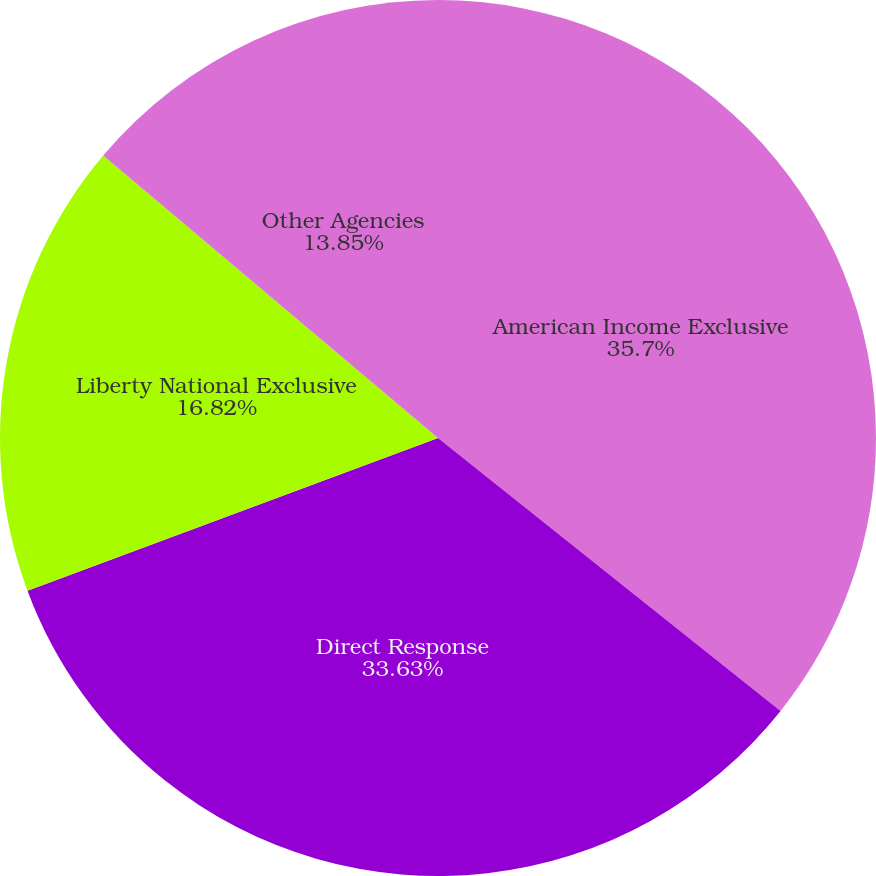<chart> <loc_0><loc_0><loc_500><loc_500><pie_chart><fcel>American Income Exclusive<fcel>Direct Response<fcel>Liberty National Exclusive<fcel>Other Agencies<nl><fcel>35.71%<fcel>33.63%<fcel>16.82%<fcel>13.85%<nl></chart> 